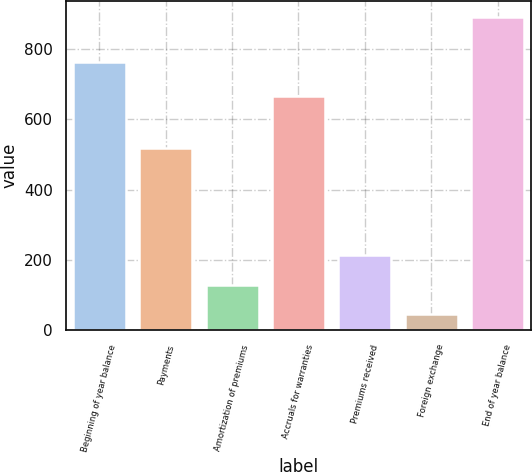Convert chart. <chart><loc_0><loc_0><loc_500><loc_500><bar_chart><fcel>Beginning of year balance<fcel>Payments<fcel>Amortization of premiums<fcel>Accruals for warranties<fcel>Premiums received<fcel>Foreign exchange<fcel>End of year balance<nl><fcel>762<fcel>517<fcel>129.7<fcel>665<fcel>214.4<fcel>45<fcel>892<nl></chart> 